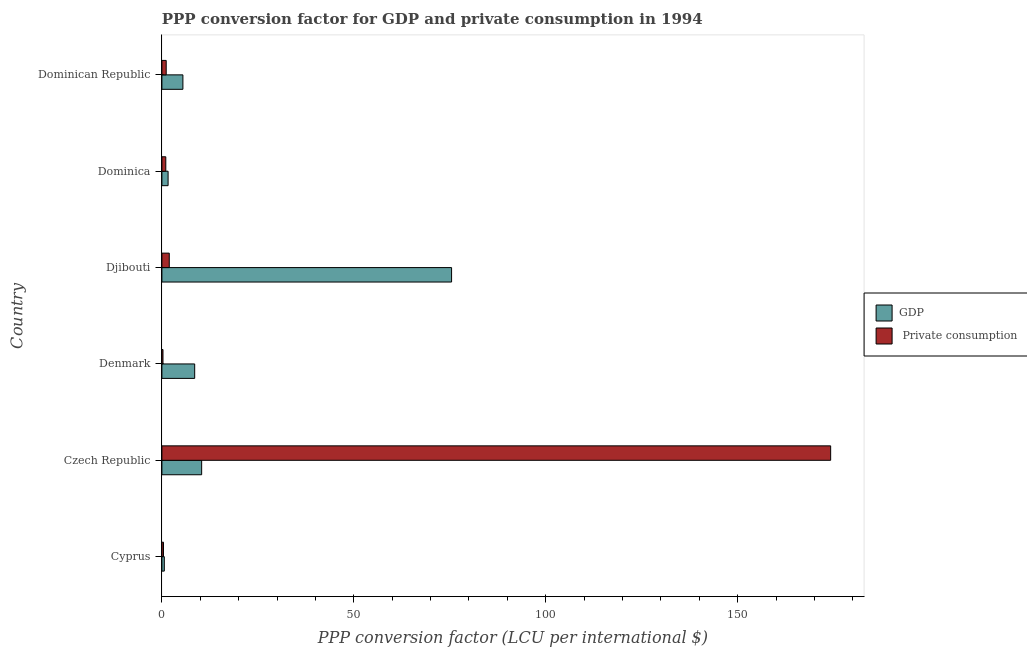Are the number of bars per tick equal to the number of legend labels?
Your answer should be very brief. Yes. Are the number of bars on each tick of the Y-axis equal?
Make the answer very short. Yes. How many bars are there on the 5th tick from the bottom?
Provide a succinct answer. 2. What is the label of the 1st group of bars from the top?
Ensure brevity in your answer.  Dominican Republic. What is the ppp conversion factor for gdp in Djibouti?
Offer a very short reply. 75.47. Across all countries, what is the maximum ppp conversion factor for private consumption?
Give a very brief answer. 174.23. Across all countries, what is the minimum ppp conversion factor for gdp?
Your answer should be very brief. 0.63. In which country was the ppp conversion factor for gdp maximum?
Provide a succinct answer. Djibouti. In which country was the ppp conversion factor for gdp minimum?
Make the answer very short. Cyprus. What is the total ppp conversion factor for private consumption in the graph?
Your answer should be very brief. 178.98. What is the difference between the ppp conversion factor for private consumption in Czech Republic and that in Dominica?
Give a very brief answer. 173.22. What is the difference between the ppp conversion factor for private consumption in Djibouti and the ppp conversion factor for gdp in Dominica?
Your answer should be very brief. 0.31. What is the average ppp conversion factor for gdp per country?
Offer a very short reply. 17.01. What is the difference between the ppp conversion factor for gdp and ppp conversion factor for private consumption in Djibouti?
Your response must be concise. 73.55. In how many countries, is the ppp conversion factor for private consumption greater than 110 LCU?
Make the answer very short. 1. What is the ratio of the ppp conversion factor for private consumption in Dominica to that in Dominican Republic?
Your answer should be very brief. 0.91. Is the ppp conversion factor for gdp in Denmark less than that in Djibouti?
Provide a succinct answer. Yes. What is the difference between the highest and the second highest ppp conversion factor for gdp?
Your response must be concise. 65.11. What is the difference between the highest and the lowest ppp conversion factor for private consumption?
Give a very brief answer. 173.95. In how many countries, is the ppp conversion factor for gdp greater than the average ppp conversion factor for gdp taken over all countries?
Your answer should be compact. 1. What does the 1st bar from the top in Denmark represents?
Give a very brief answer.  Private consumption. What does the 2nd bar from the bottom in Cyprus represents?
Give a very brief answer.  Private consumption. How many bars are there?
Give a very brief answer. 12. Are the values on the major ticks of X-axis written in scientific E-notation?
Ensure brevity in your answer.  No. Does the graph contain grids?
Keep it short and to the point. No. How many legend labels are there?
Give a very brief answer. 2. What is the title of the graph?
Offer a very short reply. PPP conversion factor for GDP and private consumption in 1994. What is the label or title of the X-axis?
Provide a succinct answer. PPP conversion factor (LCU per international $). What is the label or title of the Y-axis?
Give a very brief answer. Country. What is the PPP conversion factor (LCU per international $) in GDP in Cyprus?
Your answer should be very brief. 0.63. What is the PPP conversion factor (LCU per international $) of  Private consumption in Cyprus?
Offer a terse response. 0.41. What is the PPP conversion factor (LCU per international $) in GDP in Czech Republic?
Your response must be concise. 10.36. What is the PPP conversion factor (LCU per international $) of  Private consumption in Czech Republic?
Make the answer very short. 174.23. What is the PPP conversion factor (LCU per international $) in GDP in Denmark?
Give a very brief answer. 8.54. What is the PPP conversion factor (LCU per international $) of  Private consumption in Denmark?
Ensure brevity in your answer.  0.28. What is the PPP conversion factor (LCU per international $) of GDP in Djibouti?
Make the answer very short. 75.47. What is the PPP conversion factor (LCU per international $) in  Private consumption in Djibouti?
Your answer should be very brief. 1.92. What is the PPP conversion factor (LCU per international $) of GDP in Dominica?
Provide a short and direct response. 1.61. What is the PPP conversion factor (LCU per international $) of  Private consumption in Dominica?
Your answer should be very brief. 1.02. What is the PPP conversion factor (LCU per international $) in GDP in Dominican Republic?
Ensure brevity in your answer.  5.47. What is the PPP conversion factor (LCU per international $) in  Private consumption in Dominican Republic?
Provide a succinct answer. 1.12. Across all countries, what is the maximum PPP conversion factor (LCU per international $) of GDP?
Offer a terse response. 75.47. Across all countries, what is the maximum PPP conversion factor (LCU per international $) in  Private consumption?
Your answer should be compact. 174.23. Across all countries, what is the minimum PPP conversion factor (LCU per international $) in GDP?
Your response must be concise. 0.63. Across all countries, what is the minimum PPP conversion factor (LCU per international $) of  Private consumption?
Your answer should be very brief. 0.28. What is the total PPP conversion factor (LCU per international $) in GDP in the graph?
Offer a very short reply. 102.08. What is the total PPP conversion factor (LCU per international $) in  Private consumption in the graph?
Make the answer very short. 178.98. What is the difference between the PPP conversion factor (LCU per international $) in GDP in Cyprus and that in Czech Republic?
Your response must be concise. -9.73. What is the difference between the PPP conversion factor (LCU per international $) in  Private consumption in Cyprus and that in Czech Republic?
Your answer should be compact. -173.82. What is the difference between the PPP conversion factor (LCU per international $) in GDP in Cyprus and that in Denmark?
Ensure brevity in your answer.  -7.91. What is the difference between the PPP conversion factor (LCU per international $) in  Private consumption in Cyprus and that in Denmark?
Keep it short and to the point. 0.13. What is the difference between the PPP conversion factor (LCU per international $) in GDP in Cyprus and that in Djibouti?
Provide a short and direct response. -74.84. What is the difference between the PPP conversion factor (LCU per international $) in  Private consumption in Cyprus and that in Djibouti?
Your response must be concise. -1.51. What is the difference between the PPP conversion factor (LCU per international $) in GDP in Cyprus and that in Dominica?
Provide a short and direct response. -0.99. What is the difference between the PPP conversion factor (LCU per international $) in  Private consumption in Cyprus and that in Dominica?
Ensure brevity in your answer.  -0.6. What is the difference between the PPP conversion factor (LCU per international $) of GDP in Cyprus and that in Dominican Republic?
Give a very brief answer. -4.84. What is the difference between the PPP conversion factor (LCU per international $) of  Private consumption in Cyprus and that in Dominican Republic?
Your answer should be compact. -0.71. What is the difference between the PPP conversion factor (LCU per international $) in GDP in Czech Republic and that in Denmark?
Your response must be concise. 1.82. What is the difference between the PPP conversion factor (LCU per international $) in  Private consumption in Czech Republic and that in Denmark?
Your answer should be compact. 173.95. What is the difference between the PPP conversion factor (LCU per international $) of GDP in Czech Republic and that in Djibouti?
Your answer should be very brief. -65.11. What is the difference between the PPP conversion factor (LCU per international $) in  Private consumption in Czech Republic and that in Djibouti?
Your answer should be very brief. 172.31. What is the difference between the PPP conversion factor (LCU per international $) in GDP in Czech Republic and that in Dominica?
Ensure brevity in your answer.  8.74. What is the difference between the PPP conversion factor (LCU per international $) of  Private consumption in Czech Republic and that in Dominica?
Give a very brief answer. 173.21. What is the difference between the PPP conversion factor (LCU per international $) of GDP in Czech Republic and that in Dominican Republic?
Your response must be concise. 4.89. What is the difference between the PPP conversion factor (LCU per international $) of  Private consumption in Czech Republic and that in Dominican Republic?
Your answer should be compact. 173.11. What is the difference between the PPP conversion factor (LCU per international $) in GDP in Denmark and that in Djibouti?
Offer a terse response. -66.93. What is the difference between the PPP conversion factor (LCU per international $) of  Private consumption in Denmark and that in Djibouti?
Give a very brief answer. -1.64. What is the difference between the PPP conversion factor (LCU per international $) in GDP in Denmark and that in Dominica?
Your answer should be compact. 6.93. What is the difference between the PPP conversion factor (LCU per international $) of  Private consumption in Denmark and that in Dominica?
Your answer should be very brief. -0.74. What is the difference between the PPP conversion factor (LCU per international $) of GDP in Denmark and that in Dominican Republic?
Offer a very short reply. 3.07. What is the difference between the PPP conversion factor (LCU per international $) of  Private consumption in Denmark and that in Dominican Republic?
Keep it short and to the point. -0.84. What is the difference between the PPP conversion factor (LCU per international $) of GDP in Djibouti and that in Dominica?
Your answer should be compact. 73.86. What is the difference between the PPP conversion factor (LCU per international $) of  Private consumption in Djibouti and that in Dominica?
Provide a short and direct response. 0.9. What is the difference between the PPP conversion factor (LCU per international $) in GDP in Djibouti and that in Dominican Republic?
Your answer should be very brief. 70. What is the difference between the PPP conversion factor (LCU per international $) of  Private consumption in Djibouti and that in Dominican Republic?
Keep it short and to the point. 0.8. What is the difference between the PPP conversion factor (LCU per international $) in GDP in Dominica and that in Dominican Republic?
Provide a succinct answer. -3.86. What is the difference between the PPP conversion factor (LCU per international $) of  Private consumption in Dominica and that in Dominican Republic?
Your answer should be very brief. -0.1. What is the difference between the PPP conversion factor (LCU per international $) in GDP in Cyprus and the PPP conversion factor (LCU per international $) in  Private consumption in Czech Republic?
Offer a terse response. -173.6. What is the difference between the PPP conversion factor (LCU per international $) of GDP in Cyprus and the PPP conversion factor (LCU per international $) of  Private consumption in Denmark?
Your answer should be compact. 0.35. What is the difference between the PPP conversion factor (LCU per international $) of GDP in Cyprus and the PPP conversion factor (LCU per international $) of  Private consumption in Djibouti?
Provide a succinct answer. -1.29. What is the difference between the PPP conversion factor (LCU per international $) in GDP in Cyprus and the PPP conversion factor (LCU per international $) in  Private consumption in Dominica?
Your answer should be very brief. -0.39. What is the difference between the PPP conversion factor (LCU per international $) of GDP in Cyprus and the PPP conversion factor (LCU per international $) of  Private consumption in Dominican Republic?
Give a very brief answer. -0.49. What is the difference between the PPP conversion factor (LCU per international $) in GDP in Czech Republic and the PPP conversion factor (LCU per international $) in  Private consumption in Denmark?
Provide a succinct answer. 10.08. What is the difference between the PPP conversion factor (LCU per international $) in GDP in Czech Republic and the PPP conversion factor (LCU per international $) in  Private consumption in Djibouti?
Your response must be concise. 8.44. What is the difference between the PPP conversion factor (LCU per international $) of GDP in Czech Republic and the PPP conversion factor (LCU per international $) of  Private consumption in Dominica?
Keep it short and to the point. 9.34. What is the difference between the PPP conversion factor (LCU per international $) in GDP in Czech Republic and the PPP conversion factor (LCU per international $) in  Private consumption in Dominican Republic?
Give a very brief answer. 9.24. What is the difference between the PPP conversion factor (LCU per international $) in GDP in Denmark and the PPP conversion factor (LCU per international $) in  Private consumption in Djibouti?
Offer a very short reply. 6.62. What is the difference between the PPP conversion factor (LCU per international $) of GDP in Denmark and the PPP conversion factor (LCU per international $) of  Private consumption in Dominica?
Offer a terse response. 7.52. What is the difference between the PPP conversion factor (LCU per international $) in GDP in Denmark and the PPP conversion factor (LCU per international $) in  Private consumption in Dominican Republic?
Make the answer very short. 7.42. What is the difference between the PPP conversion factor (LCU per international $) of GDP in Djibouti and the PPP conversion factor (LCU per international $) of  Private consumption in Dominica?
Provide a succinct answer. 74.45. What is the difference between the PPP conversion factor (LCU per international $) of GDP in Djibouti and the PPP conversion factor (LCU per international $) of  Private consumption in Dominican Republic?
Make the answer very short. 74.35. What is the difference between the PPP conversion factor (LCU per international $) in GDP in Dominica and the PPP conversion factor (LCU per international $) in  Private consumption in Dominican Republic?
Provide a short and direct response. 0.49. What is the average PPP conversion factor (LCU per international $) in GDP per country?
Ensure brevity in your answer.  17.01. What is the average PPP conversion factor (LCU per international $) of  Private consumption per country?
Your answer should be compact. 29.83. What is the difference between the PPP conversion factor (LCU per international $) of GDP and PPP conversion factor (LCU per international $) of  Private consumption in Cyprus?
Provide a succinct answer. 0.22. What is the difference between the PPP conversion factor (LCU per international $) in GDP and PPP conversion factor (LCU per international $) in  Private consumption in Czech Republic?
Ensure brevity in your answer.  -163.87. What is the difference between the PPP conversion factor (LCU per international $) of GDP and PPP conversion factor (LCU per international $) of  Private consumption in Denmark?
Offer a very short reply. 8.26. What is the difference between the PPP conversion factor (LCU per international $) of GDP and PPP conversion factor (LCU per international $) of  Private consumption in Djibouti?
Give a very brief answer. 73.55. What is the difference between the PPP conversion factor (LCU per international $) of GDP and PPP conversion factor (LCU per international $) of  Private consumption in Dominica?
Ensure brevity in your answer.  0.6. What is the difference between the PPP conversion factor (LCU per international $) of GDP and PPP conversion factor (LCU per international $) of  Private consumption in Dominican Republic?
Provide a short and direct response. 4.35. What is the ratio of the PPP conversion factor (LCU per international $) of GDP in Cyprus to that in Czech Republic?
Provide a succinct answer. 0.06. What is the ratio of the PPP conversion factor (LCU per international $) in  Private consumption in Cyprus to that in Czech Republic?
Your answer should be very brief. 0. What is the ratio of the PPP conversion factor (LCU per international $) of GDP in Cyprus to that in Denmark?
Make the answer very short. 0.07. What is the ratio of the PPP conversion factor (LCU per international $) of  Private consumption in Cyprus to that in Denmark?
Make the answer very short. 1.46. What is the ratio of the PPP conversion factor (LCU per international $) of GDP in Cyprus to that in Djibouti?
Your response must be concise. 0.01. What is the ratio of the PPP conversion factor (LCU per international $) in  Private consumption in Cyprus to that in Djibouti?
Ensure brevity in your answer.  0.21. What is the ratio of the PPP conversion factor (LCU per international $) of GDP in Cyprus to that in Dominica?
Your answer should be compact. 0.39. What is the ratio of the PPP conversion factor (LCU per international $) in  Private consumption in Cyprus to that in Dominica?
Your answer should be compact. 0.41. What is the ratio of the PPP conversion factor (LCU per international $) in GDP in Cyprus to that in Dominican Republic?
Your answer should be very brief. 0.11. What is the ratio of the PPP conversion factor (LCU per international $) in  Private consumption in Cyprus to that in Dominican Republic?
Make the answer very short. 0.37. What is the ratio of the PPP conversion factor (LCU per international $) of GDP in Czech Republic to that in Denmark?
Your answer should be compact. 1.21. What is the ratio of the PPP conversion factor (LCU per international $) of  Private consumption in Czech Republic to that in Denmark?
Your response must be concise. 619.19. What is the ratio of the PPP conversion factor (LCU per international $) in GDP in Czech Republic to that in Djibouti?
Provide a succinct answer. 0.14. What is the ratio of the PPP conversion factor (LCU per international $) in  Private consumption in Czech Republic to that in Djibouti?
Offer a very short reply. 90.81. What is the ratio of the PPP conversion factor (LCU per international $) of GDP in Czech Republic to that in Dominica?
Give a very brief answer. 6.42. What is the ratio of the PPP conversion factor (LCU per international $) in  Private consumption in Czech Republic to that in Dominica?
Provide a succinct answer. 171.31. What is the ratio of the PPP conversion factor (LCU per international $) in GDP in Czech Republic to that in Dominican Republic?
Offer a very short reply. 1.89. What is the ratio of the PPP conversion factor (LCU per international $) of  Private consumption in Czech Republic to that in Dominican Republic?
Offer a terse response. 155.28. What is the ratio of the PPP conversion factor (LCU per international $) of GDP in Denmark to that in Djibouti?
Provide a succinct answer. 0.11. What is the ratio of the PPP conversion factor (LCU per international $) in  Private consumption in Denmark to that in Djibouti?
Your response must be concise. 0.15. What is the ratio of the PPP conversion factor (LCU per international $) of GDP in Denmark to that in Dominica?
Keep it short and to the point. 5.29. What is the ratio of the PPP conversion factor (LCU per international $) in  Private consumption in Denmark to that in Dominica?
Provide a short and direct response. 0.28. What is the ratio of the PPP conversion factor (LCU per international $) in GDP in Denmark to that in Dominican Republic?
Offer a terse response. 1.56. What is the ratio of the PPP conversion factor (LCU per international $) of  Private consumption in Denmark to that in Dominican Republic?
Your answer should be very brief. 0.25. What is the ratio of the PPP conversion factor (LCU per international $) in GDP in Djibouti to that in Dominica?
Your answer should be very brief. 46.78. What is the ratio of the PPP conversion factor (LCU per international $) of  Private consumption in Djibouti to that in Dominica?
Keep it short and to the point. 1.89. What is the ratio of the PPP conversion factor (LCU per international $) of GDP in Djibouti to that in Dominican Republic?
Provide a short and direct response. 13.79. What is the ratio of the PPP conversion factor (LCU per international $) of  Private consumption in Djibouti to that in Dominican Republic?
Your answer should be very brief. 1.71. What is the ratio of the PPP conversion factor (LCU per international $) of GDP in Dominica to that in Dominican Republic?
Offer a very short reply. 0.29. What is the ratio of the PPP conversion factor (LCU per international $) of  Private consumption in Dominica to that in Dominican Republic?
Offer a terse response. 0.91. What is the difference between the highest and the second highest PPP conversion factor (LCU per international $) in GDP?
Offer a terse response. 65.11. What is the difference between the highest and the second highest PPP conversion factor (LCU per international $) in  Private consumption?
Offer a very short reply. 172.31. What is the difference between the highest and the lowest PPP conversion factor (LCU per international $) in GDP?
Give a very brief answer. 74.84. What is the difference between the highest and the lowest PPP conversion factor (LCU per international $) in  Private consumption?
Ensure brevity in your answer.  173.95. 